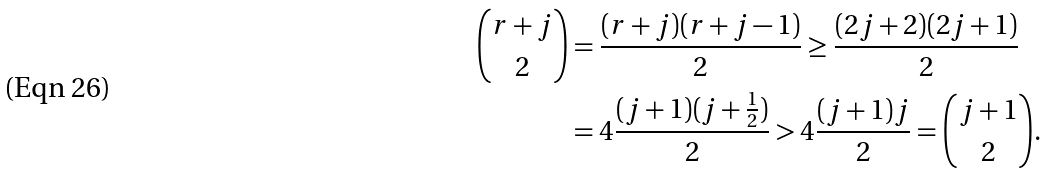Convert formula to latex. <formula><loc_0><loc_0><loc_500><loc_500>\binom { r + j } { 2 } & = \frac { ( r + j ) ( r + j - 1 ) } { 2 } \geq \frac { ( 2 j + 2 ) ( 2 j + 1 ) } { 2 } \\ & = 4 \frac { ( j + 1 ) ( j + \frac { 1 } { 2 } ) } { 2 } > 4 \frac { ( j + 1 ) j } { 2 } = \binom { j + 1 } { 2 } .</formula> 